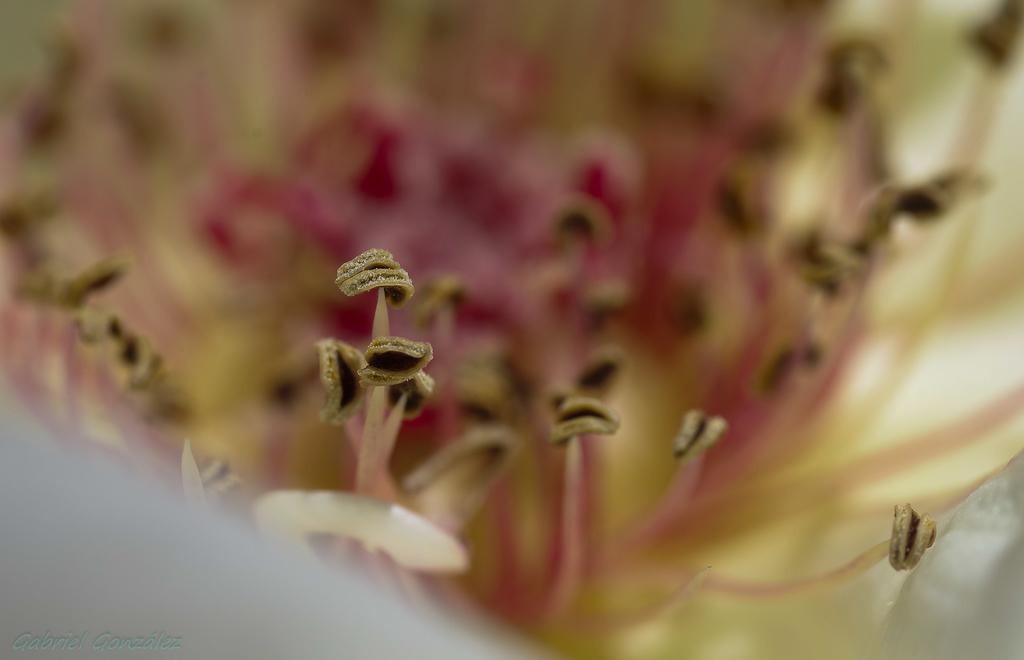In one or two sentences, can you explain what this image depicts? In this image we can see the flower parts which looks like stamens and the image is blurred. 